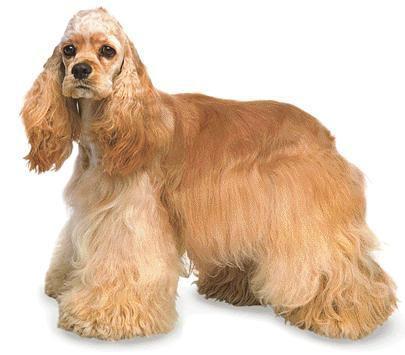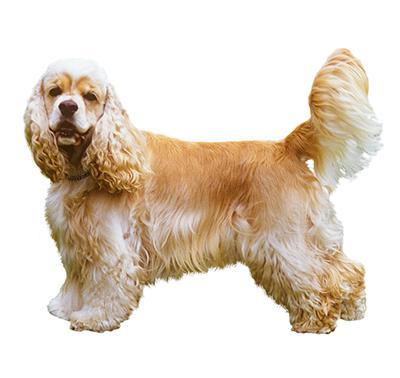The first image is the image on the left, the second image is the image on the right. For the images shown, is this caption "There are two dogs standing and facing left." true? Answer yes or no. Yes. 